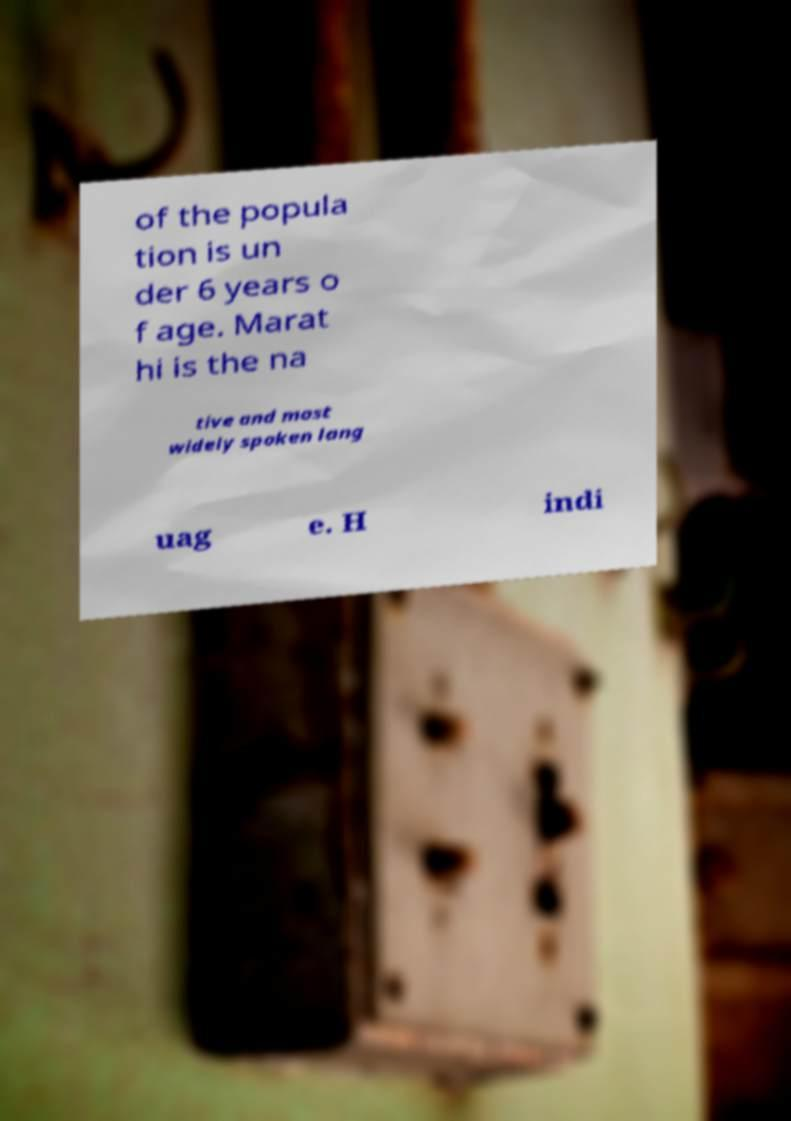Please read and relay the text visible in this image. What does it say? of the popula tion is un der 6 years o f age. Marat hi is the na tive and most widely spoken lang uag e. H indi 